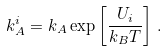<formula> <loc_0><loc_0><loc_500><loc_500>k _ { A } ^ { i } = k _ { A } \exp \left [ \frac { U _ { i } } { k _ { B } T } \right ] \, .</formula> 